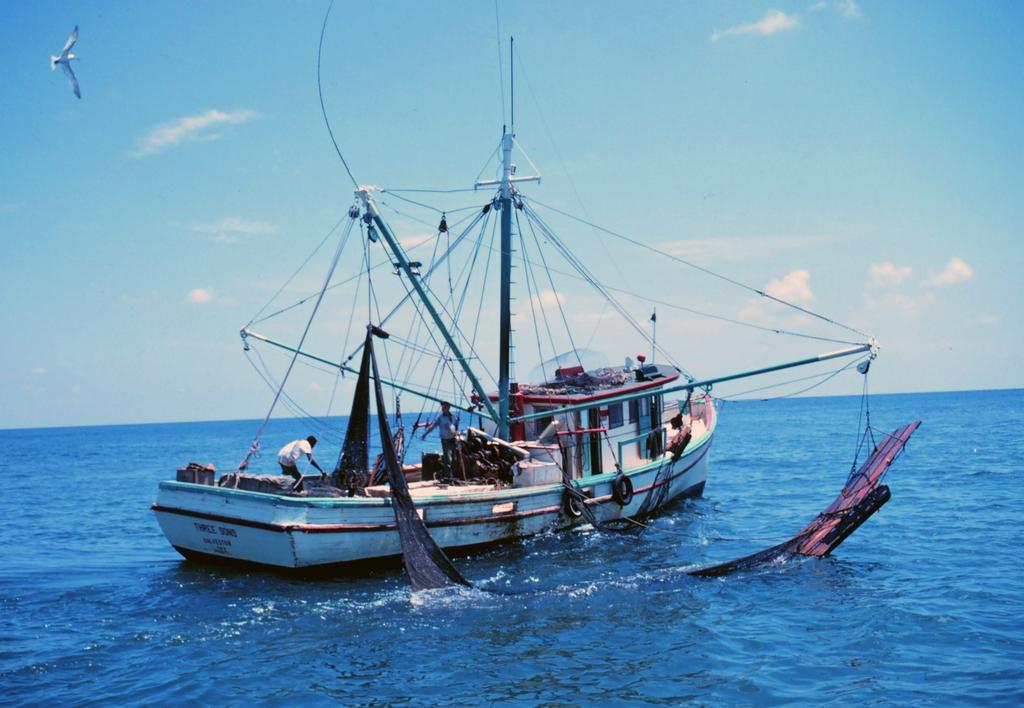Could you give a brief overview of what you see in this image? In this image there is a boat on the water , fishing net in water , and in the background there is a bird flying in the sky. 